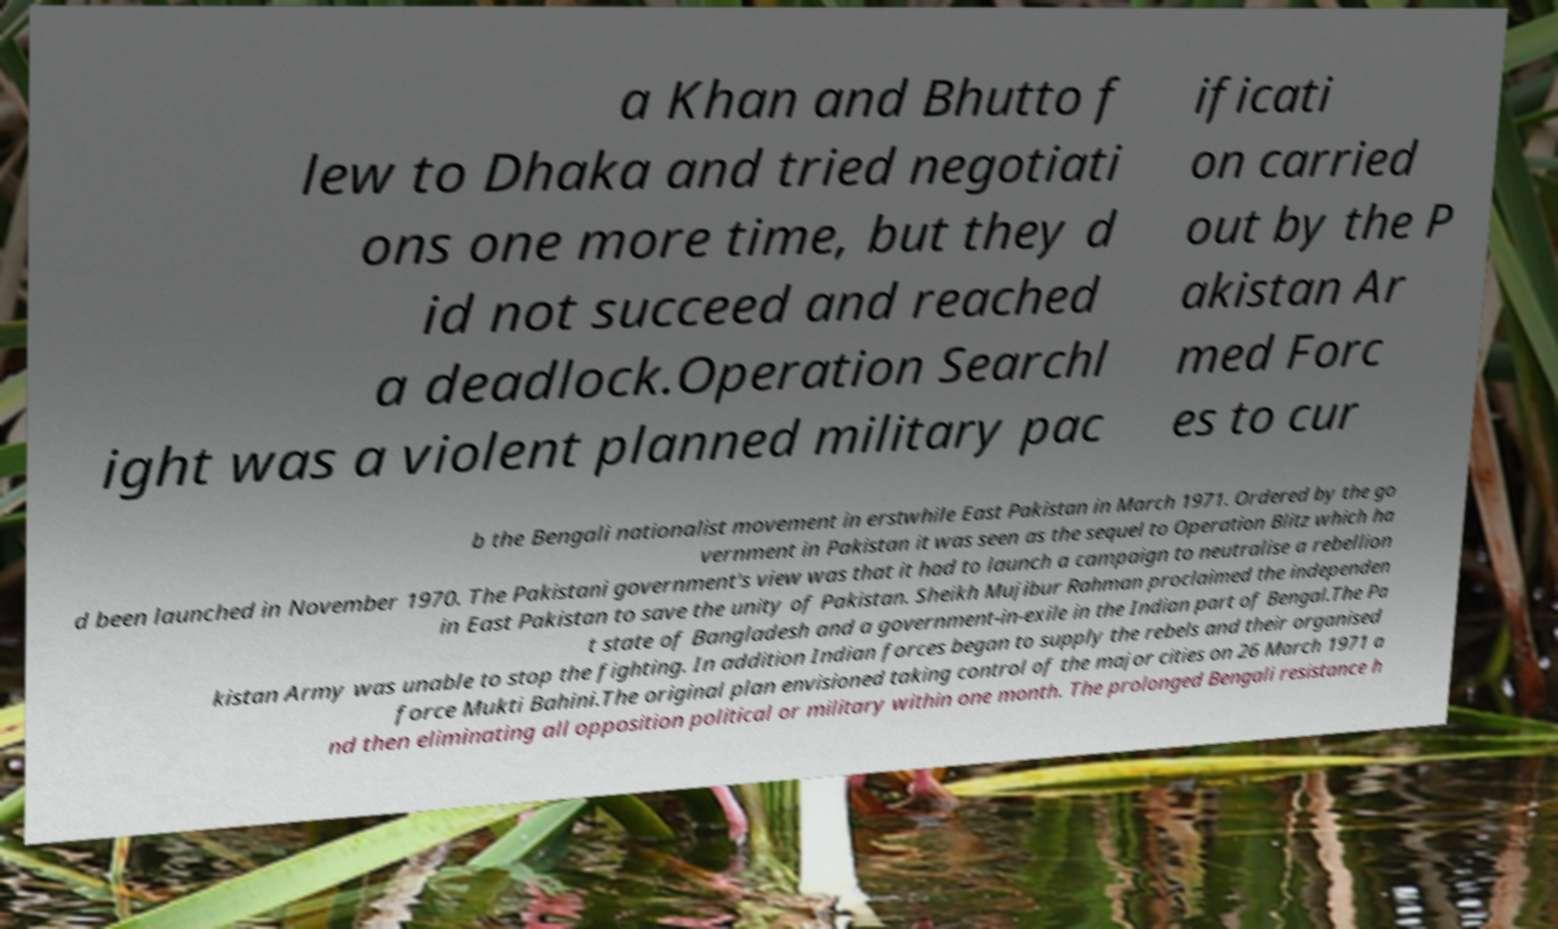What messages or text are displayed in this image? I need them in a readable, typed format. a Khan and Bhutto f lew to Dhaka and tried negotiati ons one more time, but they d id not succeed and reached a deadlock.Operation Searchl ight was a violent planned military pac ificati on carried out by the P akistan Ar med Forc es to cur b the Bengali nationalist movement in erstwhile East Pakistan in March 1971. Ordered by the go vernment in Pakistan it was seen as the sequel to Operation Blitz which ha d been launched in November 1970. The Pakistani government's view was that it had to launch a campaign to neutralise a rebellion in East Pakistan to save the unity of Pakistan. Sheikh Mujibur Rahman proclaimed the independen t state of Bangladesh and a government-in-exile in the Indian part of Bengal.The Pa kistan Army was unable to stop the fighting. In addition Indian forces began to supply the rebels and their organised force Mukti Bahini.The original plan envisioned taking control of the major cities on 26 March 1971 a nd then eliminating all opposition political or military within one month. The prolonged Bengali resistance h 